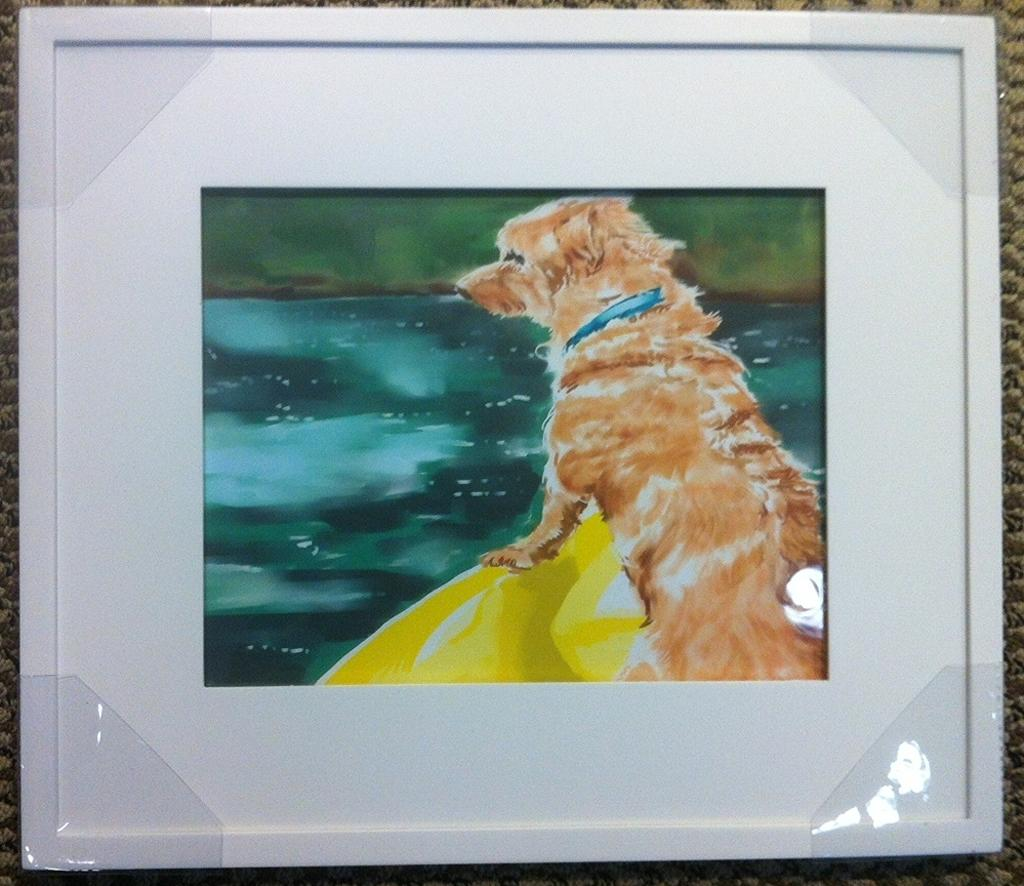What object is present in the image that typically holds a picture or photograph? There is a photo frame in the image. Where is the photo frame located in the image? The photo frame is attached to a wall. What is the subject of the painting in the photo frame? The painting in the frame depicts a dog sitting on a board. What is the background setting of the painting in the photo frame? There is water depicted in the painting. How many feathers can be seen on the dog in the painting? There are no feathers visible on the dog in the painting; it is a dog sitting on a board. 